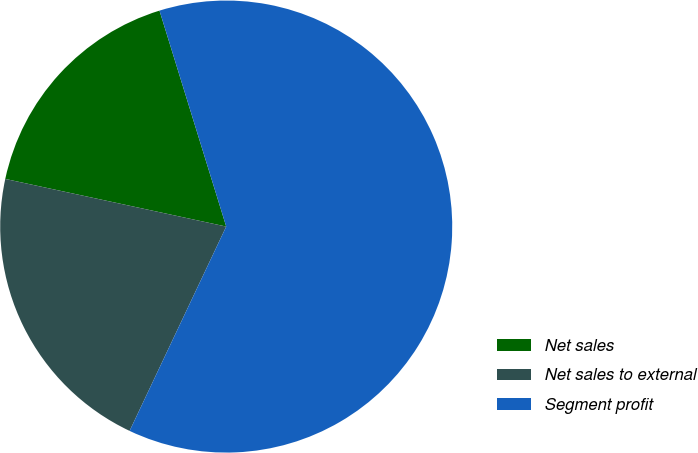Convert chart. <chart><loc_0><loc_0><loc_500><loc_500><pie_chart><fcel>Net sales<fcel>Net sales to external<fcel>Segment profit<nl><fcel>16.85%<fcel>21.35%<fcel>61.8%<nl></chart> 